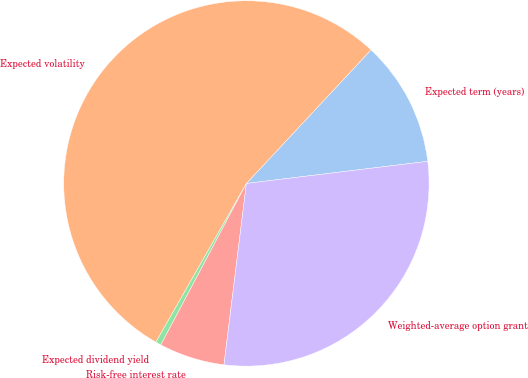<chart> <loc_0><loc_0><loc_500><loc_500><pie_chart><fcel>Expected term (years)<fcel>Expected volatility<fcel>Expected dividend yield<fcel>Risk-free interest rate<fcel>Weighted-average option grant<nl><fcel>11.12%<fcel>53.7%<fcel>0.49%<fcel>5.8%<fcel>28.89%<nl></chart> 